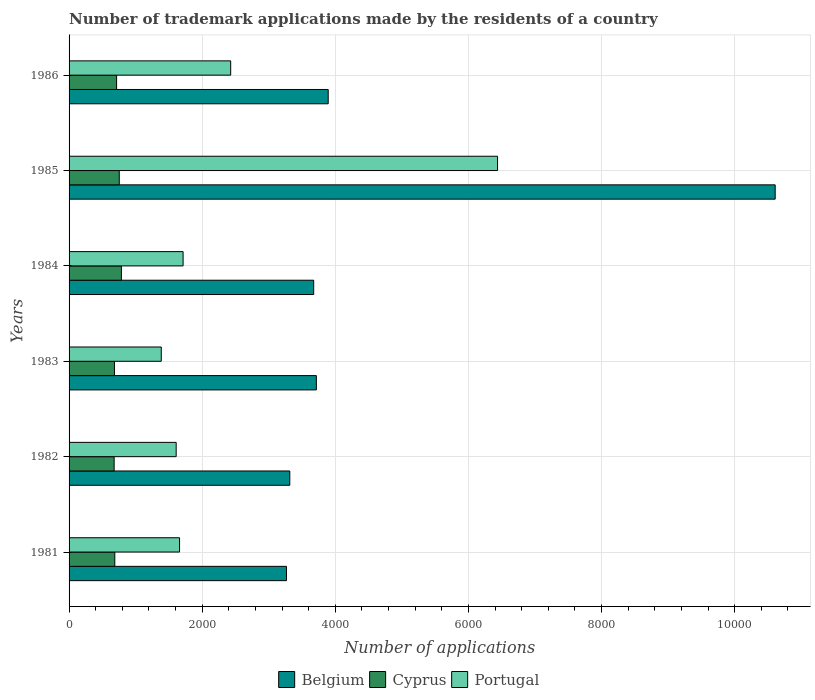Are the number of bars per tick equal to the number of legend labels?
Your answer should be very brief. Yes. Are the number of bars on each tick of the Y-axis equal?
Offer a very short reply. Yes. What is the number of trademark applications made by the residents in Cyprus in 1984?
Offer a terse response. 786. Across all years, what is the maximum number of trademark applications made by the residents in Cyprus?
Your answer should be compact. 786. Across all years, what is the minimum number of trademark applications made by the residents in Cyprus?
Offer a terse response. 677. In which year was the number of trademark applications made by the residents in Belgium minimum?
Provide a succinct answer. 1981. What is the total number of trademark applications made by the residents in Portugal in the graph?
Give a very brief answer. 1.52e+04. What is the difference between the number of trademark applications made by the residents in Belgium in 1982 and that in 1986?
Your answer should be compact. -577. What is the difference between the number of trademark applications made by the residents in Portugal in 1981 and the number of trademark applications made by the residents in Cyprus in 1986?
Your answer should be compact. 946. What is the average number of trademark applications made by the residents in Cyprus per year?
Your answer should be compact. 716.67. In the year 1984, what is the difference between the number of trademark applications made by the residents in Portugal and number of trademark applications made by the residents in Belgium?
Offer a very short reply. -1962. What is the ratio of the number of trademark applications made by the residents in Cyprus in 1981 to that in 1982?
Ensure brevity in your answer.  1.01. Is the difference between the number of trademark applications made by the residents in Portugal in 1981 and 1985 greater than the difference between the number of trademark applications made by the residents in Belgium in 1981 and 1985?
Give a very brief answer. Yes. What is the difference between the highest and the second highest number of trademark applications made by the residents in Portugal?
Make the answer very short. 4009. What is the difference between the highest and the lowest number of trademark applications made by the residents in Portugal?
Make the answer very short. 5052. In how many years, is the number of trademark applications made by the residents in Belgium greater than the average number of trademark applications made by the residents in Belgium taken over all years?
Your answer should be compact. 1. Is the sum of the number of trademark applications made by the residents in Portugal in 1981 and 1982 greater than the maximum number of trademark applications made by the residents in Belgium across all years?
Your response must be concise. No. What does the 2nd bar from the top in 1983 represents?
Your answer should be very brief. Cyprus. How many bars are there?
Provide a short and direct response. 18. Does the graph contain grids?
Your answer should be compact. Yes. Where does the legend appear in the graph?
Your answer should be compact. Bottom center. What is the title of the graph?
Provide a succinct answer. Number of trademark applications made by the residents of a country. Does "Tunisia" appear as one of the legend labels in the graph?
Keep it short and to the point. No. What is the label or title of the X-axis?
Give a very brief answer. Number of applications. What is the label or title of the Y-axis?
Your response must be concise. Years. What is the Number of applications in Belgium in 1981?
Offer a very short reply. 3266. What is the Number of applications in Cyprus in 1981?
Provide a succinct answer. 687. What is the Number of applications of Portugal in 1981?
Give a very brief answer. 1660. What is the Number of applications of Belgium in 1982?
Offer a very short reply. 3316. What is the Number of applications of Cyprus in 1982?
Provide a short and direct response. 677. What is the Number of applications of Portugal in 1982?
Your answer should be compact. 1609. What is the Number of applications in Belgium in 1983?
Ensure brevity in your answer.  3715. What is the Number of applications in Cyprus in 1983?
Offer a terse response. 682. What is the Number of applications in Portugal in 1983?
Your answer should be very brief. 1385. What is the Number of applications in Belgium in 1984?
Your response must be concise. 3675. What is the Number of applications in Cyprus in 1984?
Offer a very short reply. 786. What is the Number of applications of Portugal in 1984?
Keep it short and to the point. 1713. What is the Number of applications of Belgium in 1985?
Your response must be concise. 1.06e+04. What is the Number of applications in Cyprus in 1985?
Offer a very short reply. 754. What is the Number of applications in Portugal in 1985?
Ensure brevity in your answer.  6437. What is the Number of applications of Belgium in 1986?
Your answer should be compact. 3893. What is the Number of applications in Cyprus in 1986?
Your response must be concise. 714. What is the Number of applications in Portugal in 1986?
Offer a terse response. 2428. Across all years, what is the maximum Number of applications of Belgium?
Provide a short and direct response. 1.06e+04. Across all years, what is the maximum Number of applications in Cyprus?
Ensure brevity in your answer.  786. Across all years, what is the maximum Number of applications in Portugal?
Provide a succinct answer. 6437. Across all years, what is the minimum Number of applications of Belgium?
Provide a short and direct response. 3266. Across all years, what is the minimum Number of applications of Cyprus?
Keep it short and to the point. 677. Across all years, what is the minimum Number of applications in Portugal?
Your answer should be compact. 1385. What is the total Number of applications in Belgium in the graph?
Offer a very short reply. 2.85e+04. What is the total Number of applications of Cyprus in the graph?
Your answer should be very brief. 4300. What is the total Number of applications in Portugal in the graph?
Provide a short and direct response. 1.52e+04. What is the difference between the Number of applications in Portugal in 1981 and that in 1982?
Make the answer very short. 51. What is the difference between the Number of applications of Belgium in 1981 and that in 1983?
Offer a terse response. -449. What is the difference between the Number of applications in Cyprus in 1981 and that in 1983?
Provide a short and direct response. 5. What is the difference between the Number of applications of Portugal in 1981 and that in 1983?
Provide a short and direct response. 275. What is the difference between the Number of applications of Belgium in 1981 and that in 1984?
Your response must be concise. -409. What is the difference between the Number of applications of Cyprus in 1981 and that in 1984?
Provide a short and direct response. -99. What is the difference between the Number of applications of Portugal in 1981 and that in 1984?
Provide a succinct answer. -53. What is the difference between the Number of applications in Belgium in 1981 and that in 1985?
Your answer should be compact. -7342. What is the difference between the Number of applications in Cyprus in 1981 and that in 1985?
Your answer should be compact. -67. What is the difference between the Number of applications of Portugal in 1981 and that in 1985?
Offer a very short reply. -4777. What is the difference between the Number of applications of Belgium in 1981 and that in 1986?
Make the answer very short. -627. What is the difference between the Number of applications of Cyprus in 1981 and that in 1986?
Your answer should be compact. -27. What is the difference between the Number of applications of Portugal in 1981 and that in 1986?
Provide a succinct answer. -768. What is the difference between the Number of applications in Belgium in 1982 and that in 1983?
Your answer should be compact. -399. What is the difference between the Number of applications in Cyprus in 1982 and that in 1983?
Your response must be concise. -5. What is the difference between the Number of applications in Portugal in 1982 and that in 1983?
Your answer should be very brief. 224. What is the difference between the Number of applications in Belgium in 1982 and that in 1984?
Offer a terse response. -359. What is the difference between the Number of applications in Cyprus in 1982 and that in 1984?
Give a very brief answer. -109. What is the difference between the Number of applications in Portugal in 1982 and that in 1984?
Provide a succinct answer. -104. What is the difference between the Number of applications of Belgium in 1982 and that in 1985?
Your answer should be compact. -7292. What is the difference between the Number of applications in Cyprus in 1982 and that in 1985?
Keep it short and to the point. -77. What is the difference between the Number of applications in Portugal in 1982 and that in 1985?
Provide a succinct answer. -4828. What is the difference between the Number of applications of Belgium in 1982 and that in 1986?
Your response must be concise. -577. What is the difference between the Number of applications of Cyprus in 1982 and that in 1986?
Make the answer very short. -37. What is the difference between the Number of applications in Portugal in 1982 and that in 1986?
Provide a succinct answer. -819. What is the difference between the Number of applications of Cyprus in 1983 and that in 1984?
Your answer should be compact. -104. What is the difference between the Number of applications of Portugal in 1983 and that in 1984?
Make the answer very short. -328. What is the difference between the Number of applications of Belgium in 1983 and that in 1985?
Give a very brief answer. -6893. What is the difference between the Number of applications in Cyprus in 1983 and that in 1985?
Keep it short and to the point. -72. What is the difference between the Number of applications of Portugal in 1983 and that in 1985?
Offer a very short reply. -5052. What is the difference between the Number of applications in Belgium in 1983 and that in 1986?
Ensure brevity in your answer.  -178. What is the difference between the Number of applications in Cyprus in 1983 and that in 1986?
Make the answer very short. -32. What is the difference between the Number of applications of Portugal in 1983 and that in 1986?
Your response must be concise. -1043. What is the difference between the Number of applications in Belgium in 1984 and that in 1985?
Offer a very short reply. -6933. What is the difference between the Number of applications of Portugal in 1984 and that in 1985?
Your answer should be compact. -4724. What is the difference between the Number of applications in Belgium in 1984 and that in 1986?
Offer a very short reply. -218. What is the difference between the Number of applications of Cyprus in 1984 and that in 1986?
Your response must be concise. 72. What is the difference between the Number of applications of Portugal in 1984 and that in 1986?
Give a very brief answer. -715. What is the difference between the Number of applications in Belgium in 1985 and that in 1986?
Your response must be concise. 6715. What is the difference between the Number of applications in Portugal in 1985 and that in 1986?
Provide a short and direct response. 4009. What is the difference between the Number of applications of Belgium in 1981 and the Number of applications of Cyprus in 1982?
Offer a terse response. 2589. What is the difference between the Number of applications in Belgium in 1981 and the Number of applications in Portugal in 1982?
Keep it short and to the point. 1657. What is the difference between the Number of applications in Cyprus in 1981 and the Number of applications in Portugal in 1982?
Give a very brief answer. -922. What is the difference between the Number of applications in Belgium in 1981 and the Number of applications in Cyprus in 1983?
Ensure brevity in your answer.  2584. What is the difference between the Number of applications in Belgium in 1981 and the Number of applications in Portugal in 1983?
Provide a short and direct response. 1881. What is the difference between the Number of applications of Cyprus in 1981 and the Number of applications of Portugal in 1983?
Your response must be concise. -698. What is the difference between the Number of applications of Belgium in 1981 and the Number of applications of Cyprus in 1984?
Your answer should be compact. 2480. What is the difference between the Number of applications of Belgium in 1981 and the Number of applications of Portugal in 1984?
Ensure brevity in your answer.  1553. What is the difference between the Number of applications in Cyprus in 1981 and the Number of applications in Portugal in 1984?
Offer a very short reply. -1026. What is the difference between the Number of applications in Belgium in 1981 and the Number of applications in Cyprus in 1985?
Keep it short and to the point. 2512. What is the difference between the Number of applications of Belgium in 1981 and the Number of applications of Portugal in 1985?
Give a very brief answer. -3171. What is the difference between the Number of applications of Cyprus in 1981 and the Number of applications of Portugal in 1985?
Your response must be concise. -5750. What is the difference between the Number of applications of Belgium in 1981 and the Number of applications of Cyprus in 1986?
Provide a short and direct response. 2552. What is the difference between the Number of applications of Belgium in 1981 and the Number of applications of Portugal in 1986?
Keep it short and to the point. 838. What is the difference between the Number of applications in Cyprus in 1981 and the Number of applications in Portugal in 1986?
Offer a very short reply. -1741. What is the difference between the Number of applications in Belgium in 1982 and the Number of applications in Cyprus in 1983?
Provide a succinct answer. 2634. What is the difference between the Number of applications of Belgium in 1982 and the Number of applications of Portugal in 1983?
Make the answer very short. 1931. What is the difference between the Number of applications in Cyprus in 1982 and the Number of applications in Portugal in 1983?
Make the answer very short. -708. What is the difference between the Number of applications in Belgium in 1982 and the Number of applications in Cyprus in 1984?
Ensure brevity in your answer.  2530. What is the difference between the Number of applications of Belgium in 1982 and the Number of applications of Portugal in 1984?
Offer a very short reply. 1603. What is the difference between the Number of applications in Cyprus in 1982 and the Number of applications in Portugal in 1984?
Keep it short and to the point. -1036. What is the difference between the Number of applications of Belgium in 1982 and the Number of applications of Cyprus in 1985?
Offer a very short reply. 2562. What is the difference between the Number of applications of Belgium in 1982 and the Number of applications of Portugal in 1985?
Provide a short and direct response. -3121. What is the difference between the Number of applications of Cyprus in 1982 and the Number of applications of Portugal in 1985?
Make the answer very short. -5760. What is the difference between the Number of applications in Belgium in 1982 and the Number of applications in Cyprus in 1986?
Provide a short and direct response. 2602. What is the difference between the Number of applications in Belgium in 1982 and the Number of applications in Portugal in 1986?
Keep it short and to the point. 888. What is the difference between the Number of applications in Cyprus in 1982 and the Number of applications in Portugal in 1986?
Give a very brief answer. -1751. What is the difference between the Number of applications in Belgium in 1983 and the Number of applications in Cyprus in 1984?
Your response must be concise. 2929. What is the difference between the Number of applications in Belgium in 1983 and the Number of applications in Portugal in 1984?
Ensure brevity in your answer.  2002. What is the difference between the Number of applications in Cyprus in 1983 and the Number of applications in Portugal in 1984?
Provide a short and direct response. -1031. What is the difference between the Number of applications of Belgium in 1983 and the Number of applications of Cyprus in 1985?
Give a very brief answer. 2961. What is the difference between the Number of applications in Belgium in 1983 and the Number of applications in Portugal in 1985?
Ensure brevity in your answer.  -2722. What is the difference between the Number of applications of Cyprus in 1983 and the Number of applications of Portugal in 1985?
Your answer should be compact. -5755. What is the difference between the Number of applications of Belgium in 1983 and the Number of applications of Cyprus in 1986?
Your answer should be very brief. 3001. What is the difference between the Number of applications of Belgium in 1983 and the Number of applications of Portugal in 1986?
Offer a very short reply. 1287. What is the difference between the Number of applications in Cyprus in 1983 and the Number of applications in Portugal in 1986?
Your response must be concise. -1746. What is the difference between the Number of applications in Belgium in 1984 and the Number of applications in Cyprus in 1985?
Make the answer very short. 2921. What is the difference between the Number of applications in Belgium in 1984 and the Number of applications in Portugal in 1985?
Your response must be concise. -2762. What is the difference between the Number of applications in Cyprus in 1984 and the Number of applications in Portugal in 1985?
Your answer should be very brief. -5651. What is the difference between the Number of applications in Belgium in 1984 and the Number of applications in Cyprus in 1986?
Offer a terse response. 2961. What is the difference between the Number of applications in Belgium in 1984 and the Number of applications in Portugal in 1986?
Provide a short and direct response. 1247. What is the difference between the Number of applications in Cyprus in 1984 and the Number of applications in Portugal in 1986?
Keep it short and to the point. -1642. What is the difference between the Number of applications of Belgium in 1985 and the Number of applications of Cyprus in 1986?
Your answer should be compact. 9894. What is the difference between the Number of applications of Belgium in 1985 and the Number of applications of Portugal in 1986?
Make the answer very short. 8180. What is the difference between the Number of applications of Cyprus in 1985 and the Number of applications of Portugal in 1986?
Provide a short and direct response. -1674. What is the average Number of applications of Belgium per year?
Keep it short and to the point. 4745.5. What is the average Number of applications of Cyprus per year?
Offer a very short reply. 716.67. What is the average Number of applications of Portugal per year?
Offer a terse response. 2538.67. In the year 1981, what is the difference between the Number of applications in Belgium and Number of applications in Cyprus?
Ensure brevity in your answer.  2579. In the year 1981, what is the difference between the Number of applications in Belgium and Number of applications in Portugal?
Give a very brief answer. 1606. In the year 1981, what is the difference between the Number of applications in Cyprus and Number of applications in Portugal?
Your answer should be very brief. -973. In the year 1982, what is the difference between the Number of applications of Belgium and Number of applications of Cyprus?
Keep it short and to the point. 2639. In the year 1982, what is the difference between the Number of applications of Belgium and Number of applications of Portugal?
Provide a short and direct response. 1707. In the year 1982, what is the difference between the Number of applications in Cyprus and Number of applications in Portugal?
Offer a terse response. -932. In the year 1983, what is the difference between the Number of applications of Belgium and Number of applications of Cyprus?
Your response must be concise. 3033. In the year 1983, what is the difference between the Number of applications of Belgium and Number of applications of Portugal?
Offer a terse response. 2330. In the year 1983, what is the difference between the Number of applications in Cyprus and Number of applications in Portugal?
Give a very brief answer. -703. In the year 1984, what is the difference between the Number of applications in Belgium and Number of applications in Cyprus?
Keep it short and to the point. 2889. In the year 1984, what is the difference between the Number of applications in Belgium and Number of applications in Portugal?
Make the answer very short. 1962. In the year 1984, what is the difference between the Number of applications in Cyprus and Number of applications in Portugal?
Provide a short and direct response. -927. In the year 1985, what is the difference between the Number of applications in Belgium and Number of applications in Cyprus?
Your answer should be compact. 9854. In the year 1985, what is the difference between the Number of applications of Belgium and Number of applications of Portugal?
Provide a short and direct response. 4171. In the year 1985, what is the difference between the Number of applications in Cyprus and Number of applications in Portugal?
Your answer should be compact. -5683. In the year 1986, what is the difference between the Number of applications of Belgium and Number of applications of Cyprus?
Ensure brevity in your answer.  3179. In the year 1986, what is the difference between the Number of applications in Belgium and Number of applications in Portugal?
Give a very brief answer. 1465. In the year 1986, what is the difference between the Number of applications of Cyprus and Number of applications of Portugal?
Provide a succinct answer. -1714. What is the ratio of the Number of applications of Belgium in 1981 to that in 1982?
Ensure brevity in your answer.  0.98. What is the ratio of the Number of applications in Cyprus in 1981 to that in 1982?
Give a very brief answer. 1.01. What is the ratio of the Number of applications of Portugal in 1981 to that in 1982?
Provide a succinct answer. 1.03. What is the ratio of the Number of applications of Belgium in 1981 to that in 1983?
Offer a very short reply. 0.88. What is the ratio of the Number of applications in Cyprus in 1981 to that in 1983?
Offer a terse response. 1.01. What is the ratio of the Number of applications in Portugal in 1981 to that in 1983?
Your response must be concise. 1.2. What is the ratio of the Number of applications of Belgium in 1981 to that in 1984?
Provide a short and direct response. 0.89. What is the ratio of the Number of applications in Cyprus in 1981 to that in 1984?
Offer a terse response. 0.87. What is the ratio of the Number of applications in Portugal in 1981 to that in 1984?
Give a very brief answer. 0.97. What is the ratio of the Number of applications of Belgium in 1981 to that in 1985?
Provide a short and direct response. 0.31. What is the ratio of the Number of applications of Cyprus in 1981 to that in 1985?
Ensure brevity in your answer.  0.91. What is the ratio of the Number of applications of Portugal in 1981 to that in 1985?
Give a very brief answer. 0.26. What is the ratio of the Number of applications in Belgium in 1981 to that in 1986?
Offer a terse response. 0.84. What is the ratio of the Number of applications in Cyprus in 1981 to that in 1986?
Your answer should be very brief. 0.96. What is the ratio of the Number of applications in Portugal in 1981 to that in 1986?
Give a very brief answer. 0.68. What is the ratio of the Number of applications in Belgium in 1982 to that in 1983?
Provide a succinct answer. 0.89. What is the ratio of the Number of applications of Portugal in 1982 to that in 1983?
Make the answer very short. 1.16. What is the ratio of the Number of applications in Belgium in 1982 to that in 1984?
Give a very brief answer. 0.9. What is the ratio of the Number of applications in Cyprus in 1982 to that in 1984?
Give a very brief answer. 0.86. What is the ratio of the Number of applications of Portugal in 1982 to that in 1984?
Offer a terse response. 0.94. What is the ratio of the Number of applications in Belgium in 1982 to that in 1985?
Offer a terse response. 0.31. What is the ratio of the Number of applications of Cyprus in 1982 to that in 1985?
Ensure brevity in your answer.  0.9. What is the ratio of the Number of applications of Belgium in 1982 to that in 1986?
Your response must be concise. 0.85. What is the ratio of the Number of applications in Cyprus in 1982 to that in 1986?
Your answer should be very brief. 0.95. What is the ratio of the Number of applications in Portugal in 1982 to that in 1986?
Offer a very short reply. 0.66. What is the ratio of the Number of applications of Belgium in 1983 to that in 1984?
Your answer should be very brief. 1.01. What is the ratio of the Number of applications of Cyprus in 1983 to that in 1984?
Offer a very short reply. 0.87. What is the ratio of the Number of applications in Portugal in 1983 to that in 1984?
Offer a terse response. 0.81. What is the ratio of the Number of applications of Belgium in 1983 to that in 1985?
Provide a succinct answer. 0.35. What is the ratio of the Number of applications of Cyprus in 1983 to that in 1985?
Give a very brief answer. 0.9. What is the ratio of the Number of applications in Portugal in 1983 to that in 1985?
Offer a terse response. 0.22. What is the ratio of the Number of applications of Belgium in 1983 to that in 1986?
Provide a succinct answer. 0.95. What is the ratio of the Number of applications of Cyprus in 1983 to that in 1986?
Give a very brief answer. 0.96. What is the ratio of the Number of applications in Portugal in 1983 to that in 1986?
Your response must be concise. 0.57. What is the ratio of the Number of applications in Belgium in 1984 to that in 1985?
Ensure brevity in your answer.  0.35. What is the ratio of the Number of applications of Cyprus in 1984 to that in 1985?
Make the answer very short. 1.04. What is the ratio of the Number of applications of Portugal in 1984 to that in 1985?
Give a very brief answer. 0.27. What is the ratio of the Number of applications of Belgium in 1984 to that in 1986?
Make the answer very short. 0.94. What is the ratio of the Number of applications in Cyprus in 1984 to that in 1986?
Offer a terse response. 1.1. What is the ratio of the Number of applications of Portugal in 1984 to that in 1986?
Offer a very short reply. 0.71. What is the ratio of the Number of applications of Belgium in 1985 to that in 1986?
Your answer should be very brief. 2.72. What is the ratio of the Number of applications in Cyprus in 1985 to that in 1986?
Provide a succinct answer. 1.06. What is the ratio of the Number of applications of Portugal in 1985 to that in 1986?
Your response must be concise. 2.65. What is the difference between the highest and the second highest Number of applications in Belgium?
Offer a very short reply. 6715. What is the difference between the highest and the second highest Number of applications in Cyprus?
Provide a short and direct response. 32. What is the difference between the highest and the second highest Number of applications of Portugal?
Your response must be concise. 4009. What is the difference between the highest and the lowest Number of applications of Belgium?
Offer a very short reply. 7342. What is the difference between the highest and the lowest Number of applications of Cyprus?
Offer a very short reply. 109. What is the difference between the highest and the lowest Number of applications of Portugal?
Your answer should be very brief. 5052. 